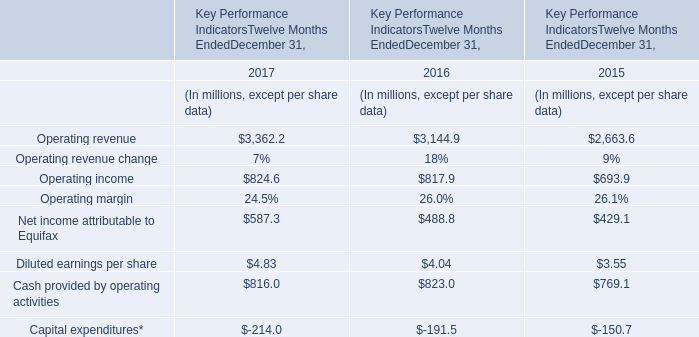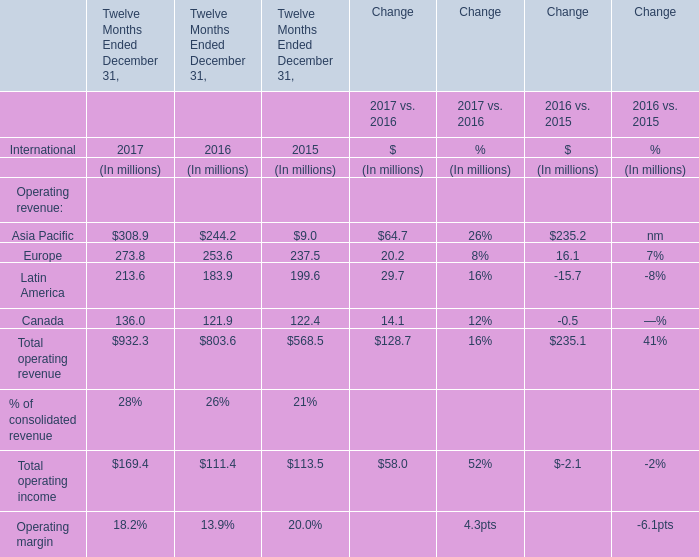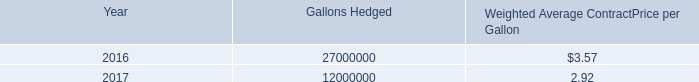In the year with the most Europe, what is the growth rate of Canada? 
Computations: ((136.0 - 121.9) / 121.9)
Answer: 0.11567. 